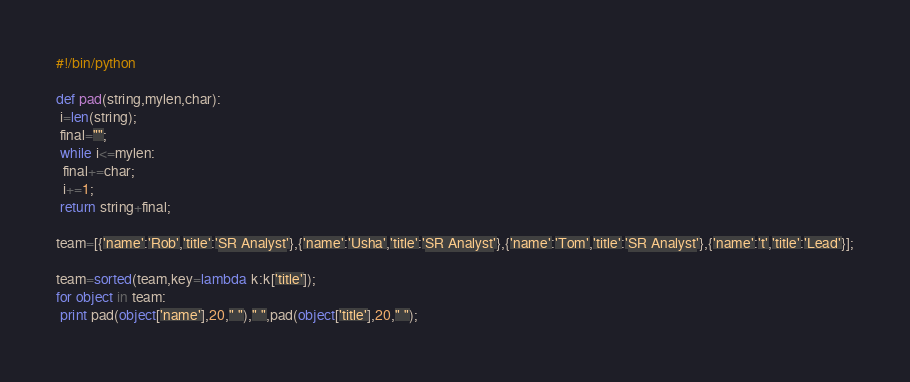Convert code to text. <code><loc_0><loc_0><loc_500><loc_500><_Python_>#!/bin/python

def pad(string,mylen,char):
 i=len(string);
 final="";
 while i<=mylen:
  final+=char;
  i+=1;
 return string+final;

team=[{'name':'Rob','title':'SR Analyst'},{'name':'Usha','title':'SR Analyst'},{'name':'Tom','title':'SR Analyst'},{'name':'t','title':'Lead'}];

team=sorted(team,key=lambda k:k['title']);
for object in team:
 print pad(object['name'],20," ")," ",pad(object['title'],20," ");
</code> 